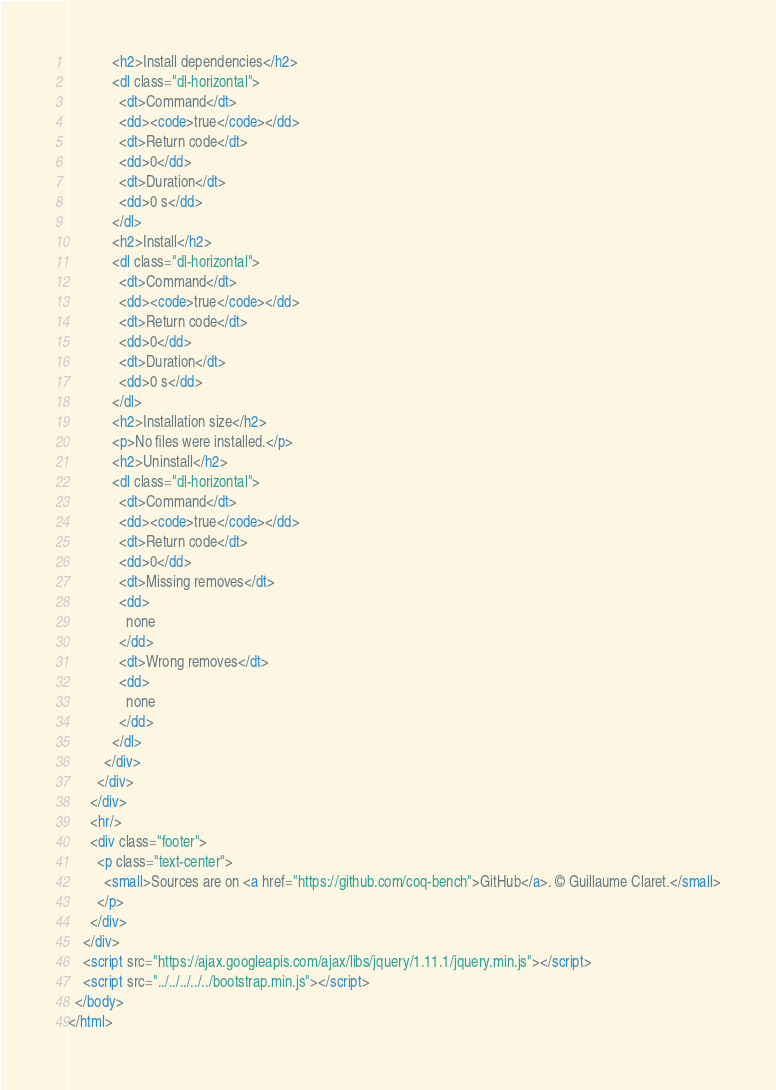Convert code to text. <code><loc_0><loc_0><loc_500><loc_500><_HTML_>            <h2>Install dependencies</h2>
            <dl class="dl-horizontal">
              <dt>Command</dt>
              <dd><code>true</code></dd>
              <dt>Return code</dt>
              <dd>0</dd>
              <dt>Duration</dt>
              <dd>0 s</dd>
            </dl>
            <h2>Install</h2>
            <dl class="dl-horizontal">
              <dt>Command</dt>
              <dd><code>true</code></dd>
              <dt>Return code</dt>
              <dd>0</dd>
              <dt>Duration</dt>
              <dd>0 s</dd>
            </dl>
            <h2>Installation size</h2>
            <p>No files were installed.</p>
            <h2>Uninstall</h2>
            <dl class="dl-horizontal">
              <dt>Command</dt>
              <dd><code>true</code></dd>
              <dt>Return code</dt>
              <dd>0</dd>
              <dt>Missing removes</dt>
              <dd>
                none
              </dd>
              <dt>Wrong removes</dt>
              <dd>
                none
              </dd>
            </dl>
          </div>
        </div>
      </div>
      <hr/>
      <div class="footer">
        <p class="text-center">
          <small>Sources are on <a href="https://github.com/coq-bench">GitHub</a>. © Guillaume Claret.</small>
        </p>
      </div>
    </div>
    <script src="https://ajax.googleapis.com/ajax/libs/jquery/1.11.1/jquery.min.js"></script>
    <script src="../../../../../bootstrap.min.js"></script>
  </body>
</html>
</code> 